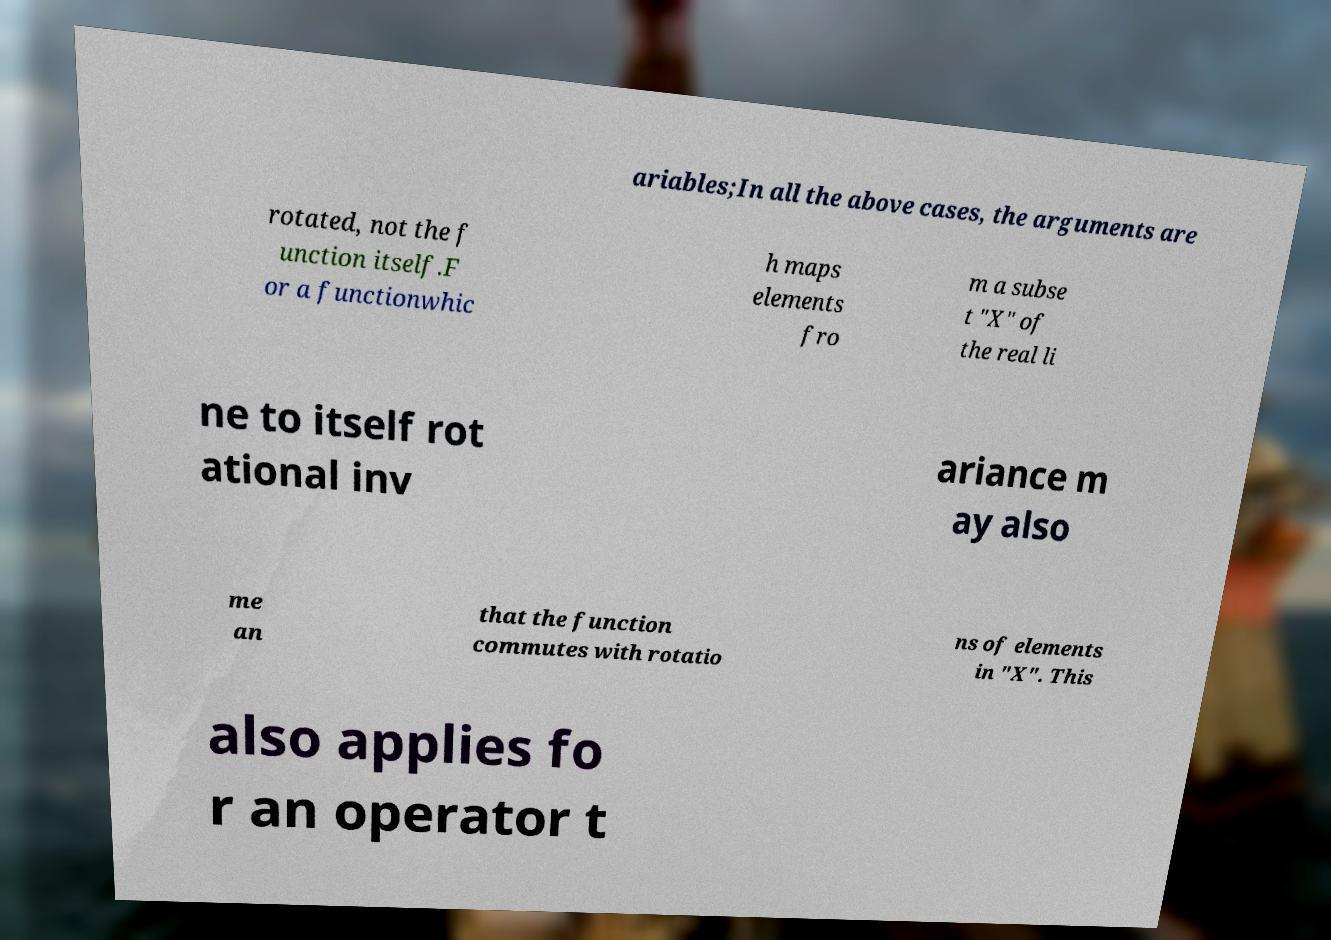Can you accurately transcribe the text from the provided image for me? ariables;In all the above cases, the arguments are rotated, not the f unction itself.F or a functionwhic h maps elements fro m a subse t "X" of the real li ne to itself rot ational inv ariance m ay also me an that the function commutes with rotatio ns of elements in "X". This also applies fo r an operator t 